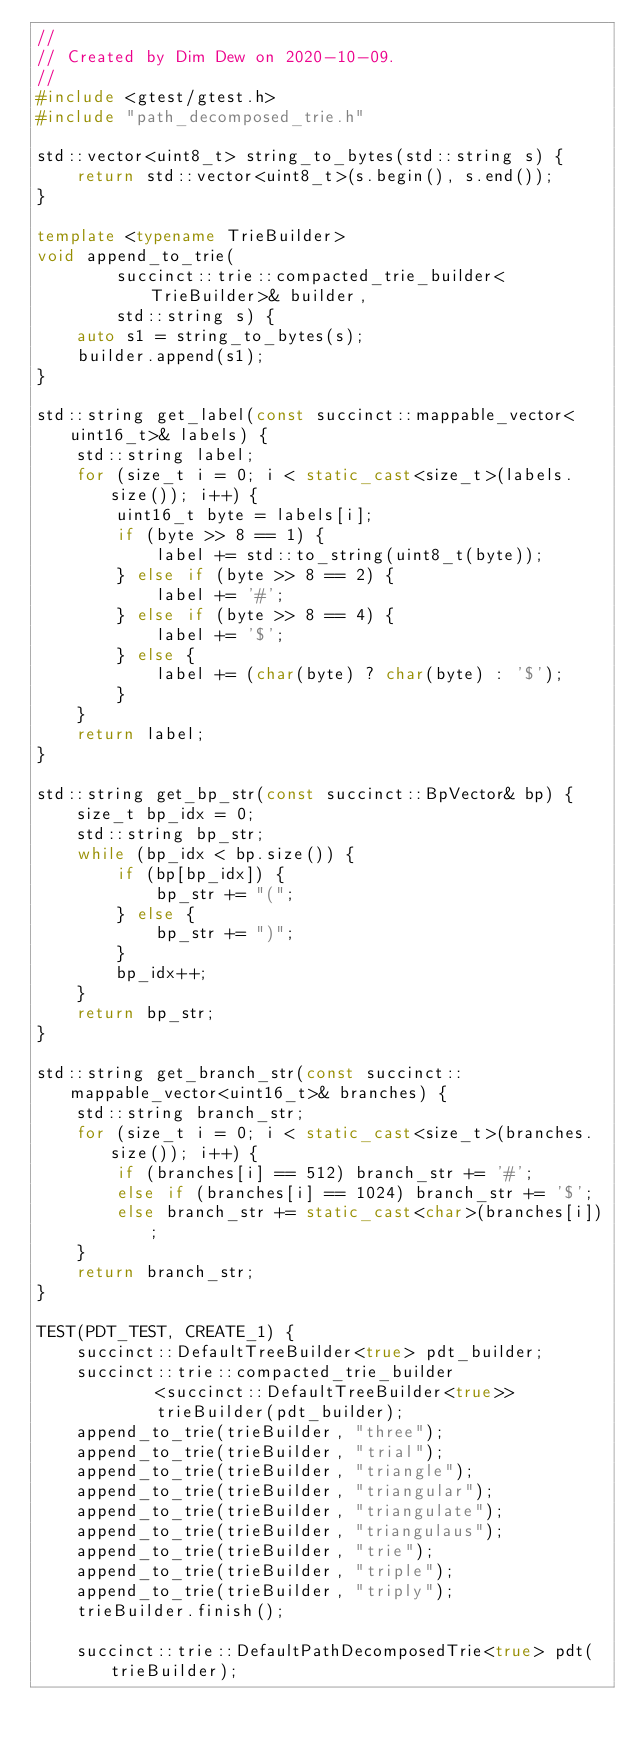<code> <loc_0><loc_0><loc_500><loc_500><_C++_>//
// Created by Dim Dew on 2020-10-09.
//
#include <gtest/gtest.h>
#include "path_decomposed_trie.h"

std::vector<uint8_t> string_to_bytes(std::string s) {
    return std::vector<uint8_t>(s.begin(), s.end());
}

template <typename TrieBuilder>
void append_to_trie(
        succinct::trie::compacted_trie_builder<TrieBuilder>& builder,
        std::string s) {
    auto s1 = string_to_bytes(s);
    builder.append(s1);
}

std::string get_label(const succinct::mappable_vector<uint16_t>& labels) {
    std::string label;
    for (size_t i = 0; i < static_cast<size_t>(labels.size()); i++) {
        uint16_t byte = labels[i];
        if (byte >> 8 == 1) {
            label += std::to_string(uint8_t(byte));
        } else if (byte >> 8 == 2) {
            label += '#';
        } else if (byte >> 8 == 4) {
            label += '$';
        } else {
            label += (char(byte) ? char(byte) : '$');
        }
    }
    return label;
}

std::string get_bp_str(const succinct::BpVector& bp) {
    size_t bp_idx = 0;
    std::string bp_str;
    while (bp_idx < bp.size()) {
        if (bp[bp_idx]) {
            bp_str += "(";
        } else {
            bp_str += ")";
        }
        bp_idx++;
    }
    return bp_str;
}

std::string get_branch_str(const succinct::mappable_vector<uint16_t>& branches) {
    std::string branch_str;
    for (size_t i = 0; i < static_cast<size_t>(branches.size()); i++) {
        if (branches[i] == 512) branch_str += '#';
        else if (branches[i] == 1024) branch_str += '$';
        else branch_str += static_cast<char>(branches[i]);
    }
    return branch_str;
}

TEST(PDT_TEST, CREATE_1) {
    succinct::DefaultTreeBuilder<true> pdt_builder;
    succinct::trie::compacted_trie_builder
            <succinct::DefaultTreeBuilder<true>>
            trieBuilder(pdt_builder);
    append_to_trie(trieBuilder, "three");
    append_to_trie(trieBuilder, "trial");
    append_to_trie(trieBuilder, "triangle");
    append_to_trie(trieBuilder, "triangular");
    append_to_trie(trieBuilder, "triangulate");
    append_to_trie(trieBuilder, "triangulaus");
    append_to_trie(trieBuilder, "trie");
    append_to_trie(trieBuilder, "triple");
    append_to_trie(trieBuilder, "triply");
    trieBuilder.finish();

    succinct::trie::DefaultPathDecomposedTrie<true> pdt(trieBuilder);</code> 